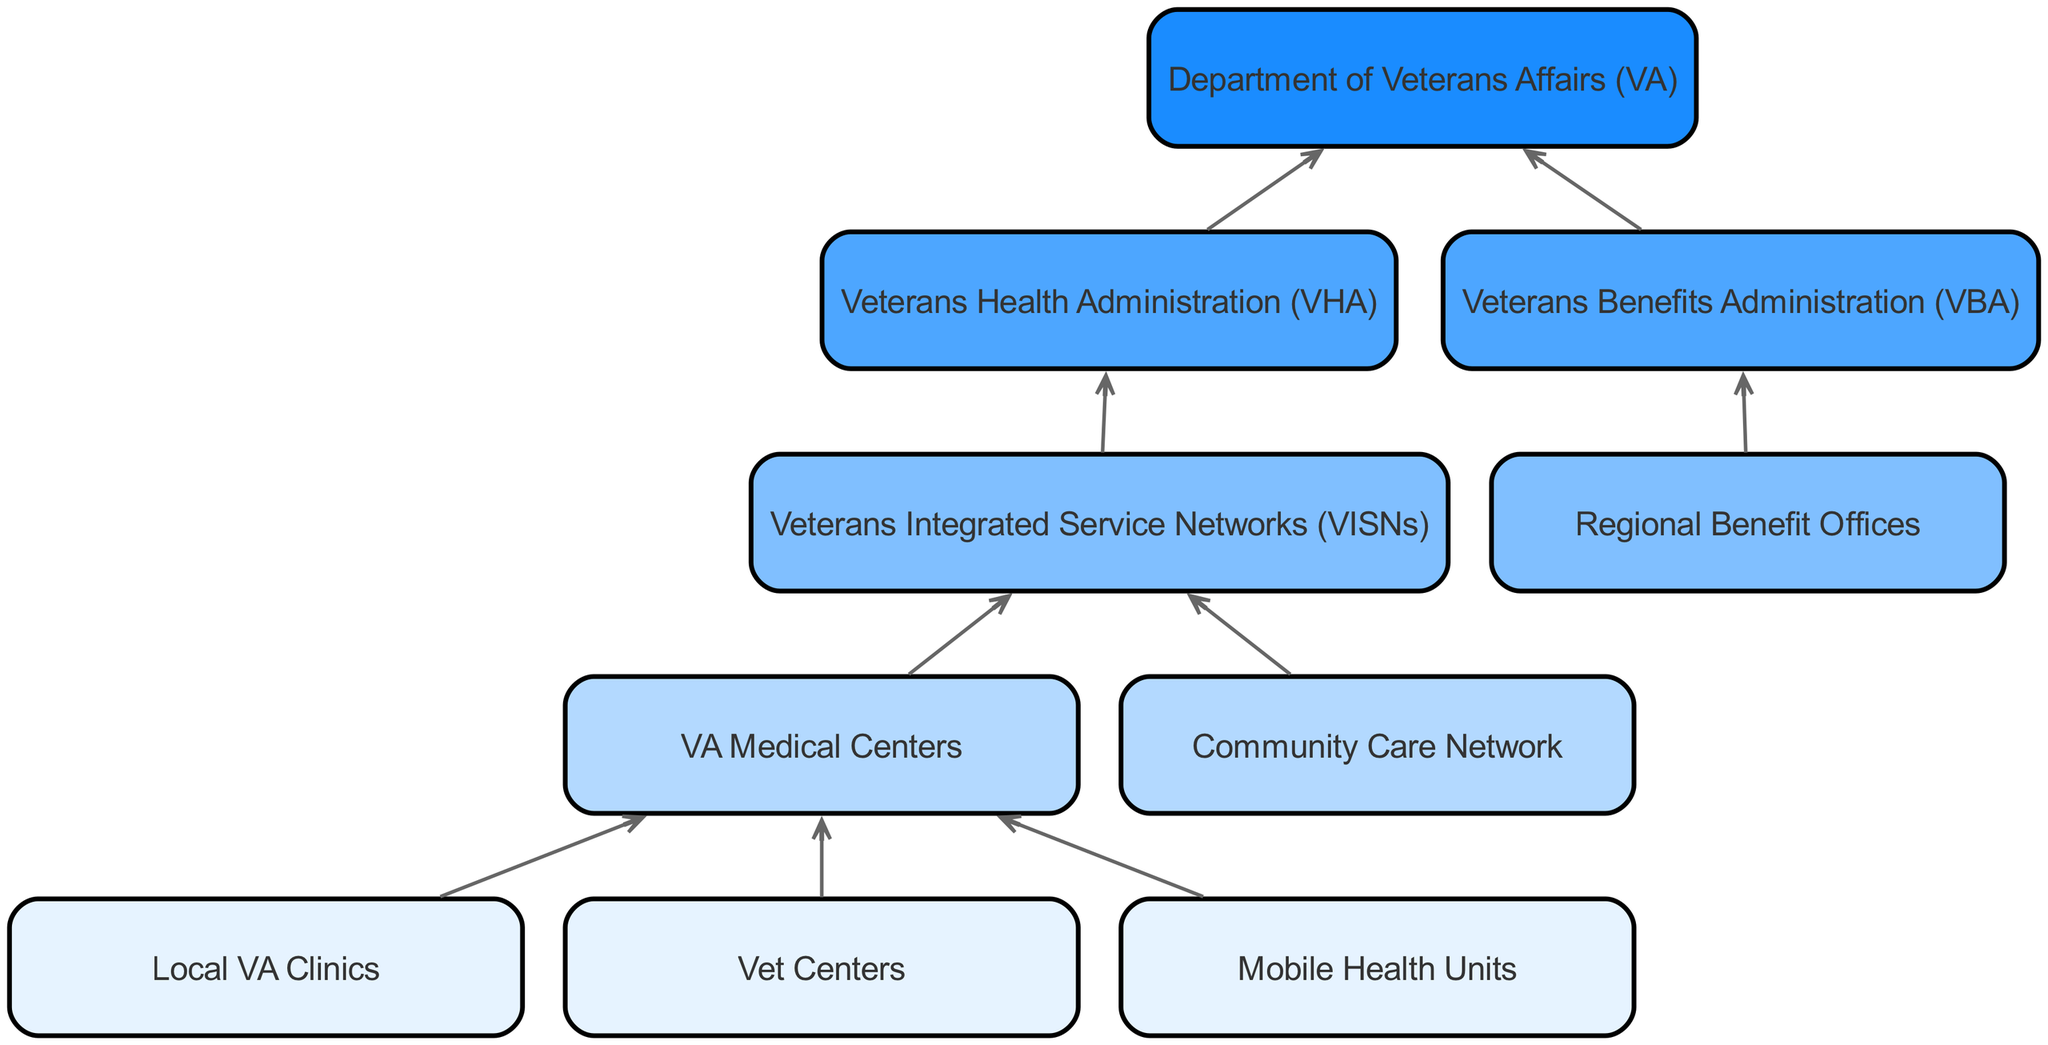What are the three types of local care facilities? The diagram lists "Local VA Clinics," "Vet Centers," and "Mobile Health Units" as the types of local care facilities.
Answer: Local VA Clinics, Vet Centers, Mobile Health Units How many levels are in the VA healthcare system structure? The diagram shows five distinct levels, starting from local clinics to the national level.
Answer: 5 Which node connects to the Veterans Integrated Service Networks? The edges show that both "VA Medical Centers" and "Community Care Network" connect to "Veterans Integrated Service Networks (VISNs)."
Answer: VA Medical Centers, Community Care Network What is the relationship between the Veterans Health Administration and the Department of Veterans Affairs? The diagram indicates that "Veterans Health Administration (VHA)" flows into "Department of Veterans Affairs (VA)," showing a direct connection from one to the other.
Answer: Flow What is the highest level in the VA healthcare system structure? The structure identifies "Department of Veterans Affairs (VA)" as the highest level within the healthcare system.
Answer: Department of Veterans Affairs (VA) How many nodes are at level 4? At level 4, there are two nodes present: "Veterans Health Administration (VHA)" and "Veterans Benefits Administration (VBA)."
Answer: 2 Which local facility connects to the VA Medical Centers? The diagram illustrates that "Local VA Clinics," "Vet Centers," and "Mobile Health Units" all connect to "VA Medical Centers."
Answer: Local VA Clinics, Vet Centers, Mobile Health Units What are the two branches at level 4 of the healthcare structure? The diagram reveals that the two branches at level 4 are "Veterans Health Administration (VHA)" and "Veterans Benefits Administration (VBA)."
Answer: Veterans Health Administration (VHA), Veterans Benefits Administration (VBA) How many connections lead to the Department of Veterans Affairs? According to the diagram, there are two connections leading to "Department of Veterans Affairs (VA)" from "Veterans Health Administration (VHA)" and "Veterans Benefits Administration (VBA)."
Answer: 2 